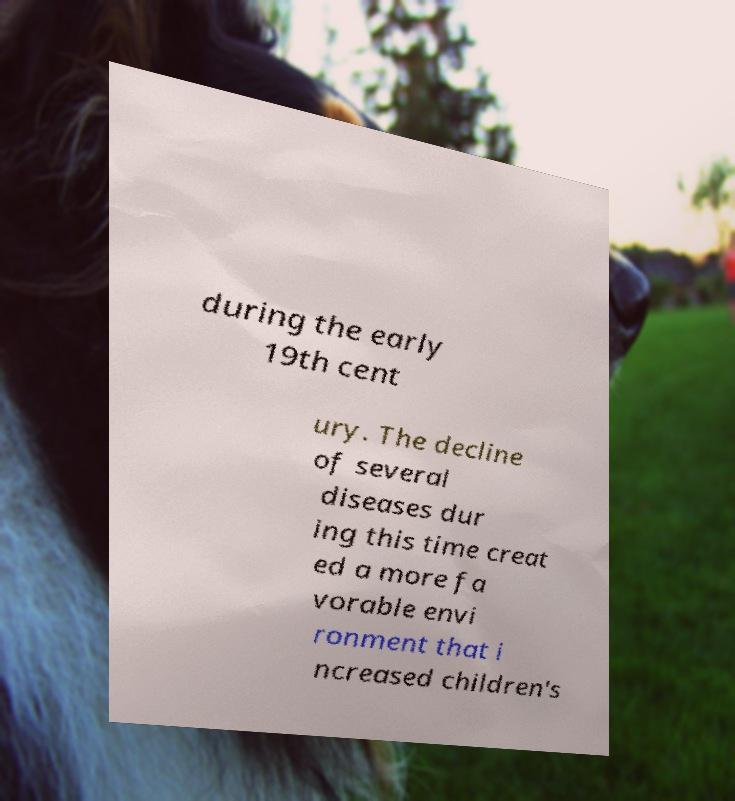What messages or text are displayed in this image? I need them in a readable, typed format. during the early 19th cent ury. The decline of several diseases dur ing this time creat ed a more fa vorable envi ronment that i ncreased children's 